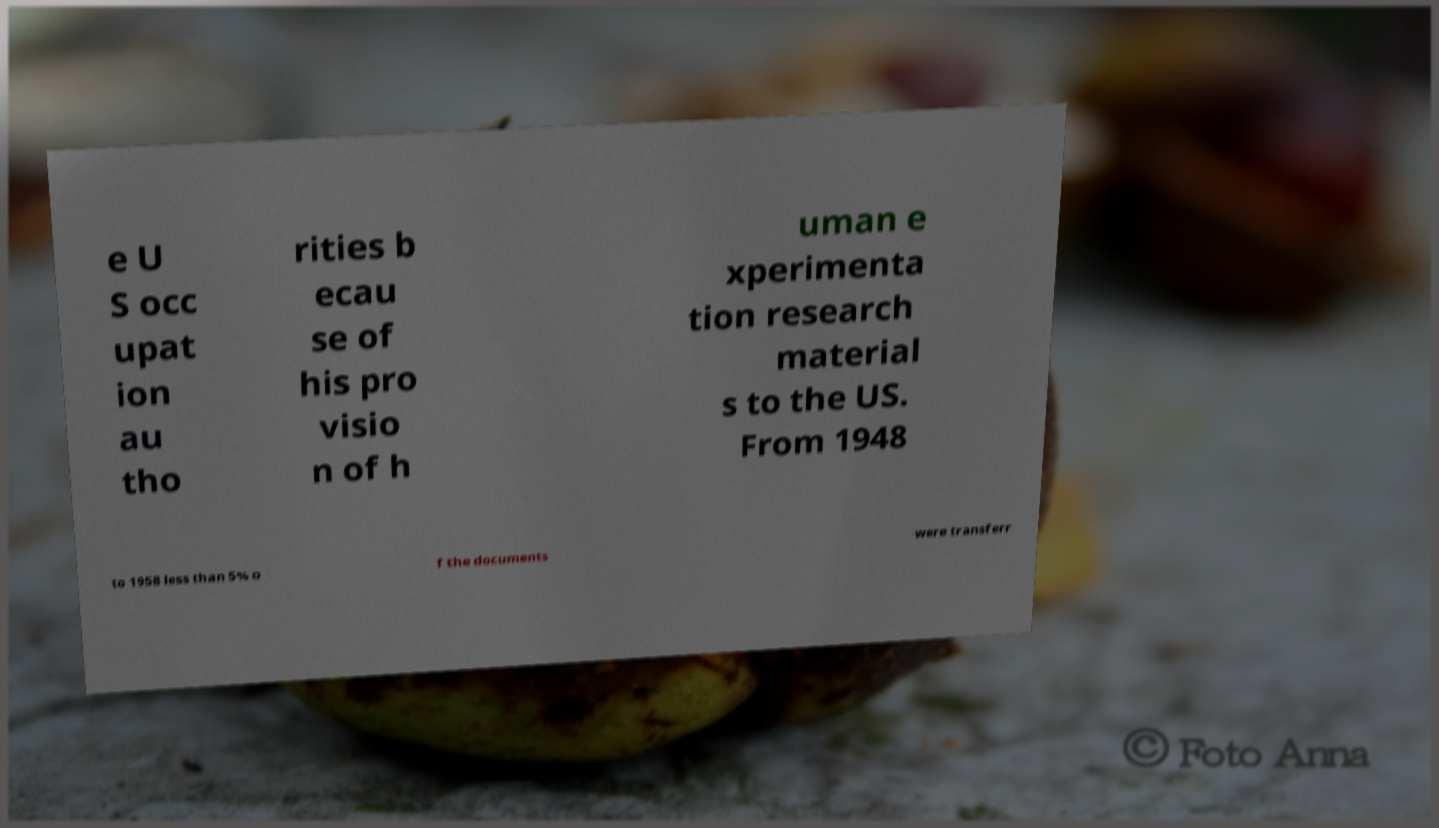Can you accurately transcribe the text from the provided image for me? e U S occ upat ion au tho rities b ecau se of his pro visio n of h uman e xperimenta tion research material s to the US. From 1948 to 1958 less than 5% o f the documents were transferr 